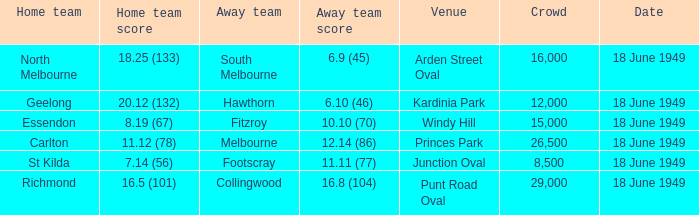What is the away team score when home team score is 20.12 (132)? 6.10 (46). 